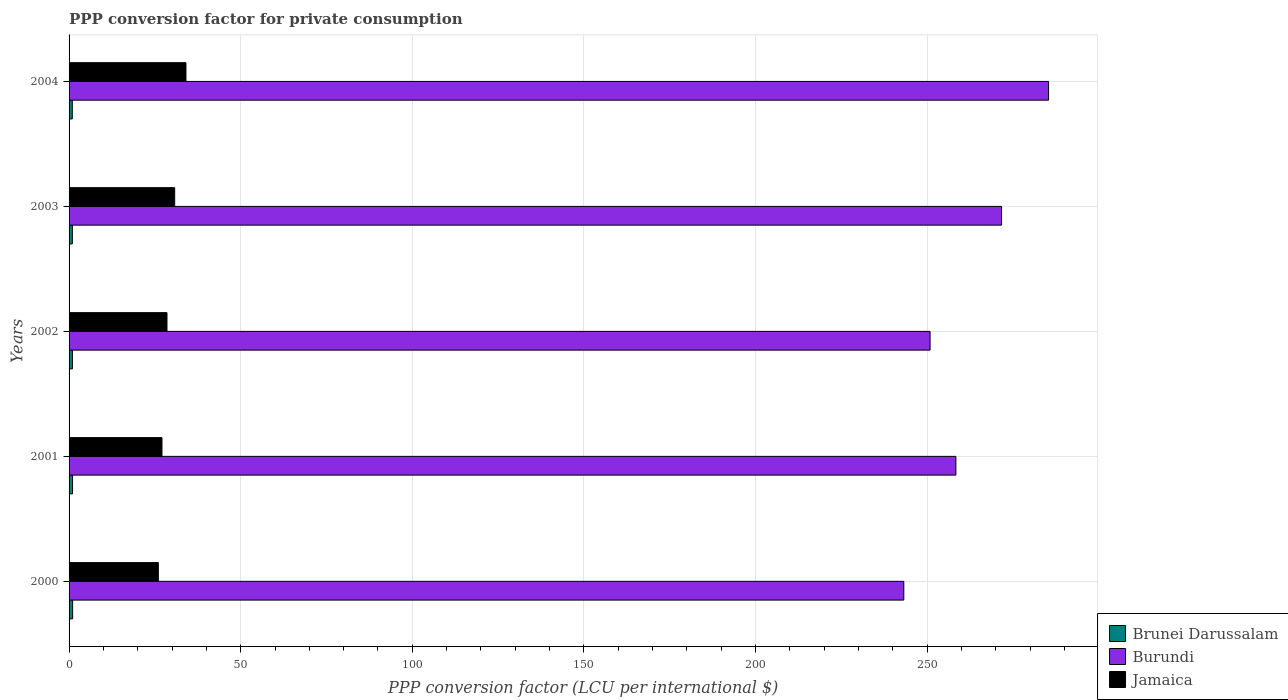How many different coloured bars are there?
Your answer should be compact. 3. How many groups of bars are there?
Provide a succinct answer. 5. Are the number of bars per tick equal to the number of legend labels?
Offer a terse response. Yes. Are the number of bars on each tick of the Y-axis equal?
Make the answer very short. Yes. How many bars are there on the 4th tick from the bottom?
Your response must be concise. 3. What is the label of the 3rd group of bars from the top?
Your answer should be compact. 2002. What is the PPP conversion factor for private consumption in Brunei Darussalam in 2003?
Ensure brevity in your answer.  0.96. Across all years, what is the maximum PPP conversion factor for private consumption in Jamaica?
Your answer should be compact. 34.06. Across all years, what is the minimum PPP conversion factor for private consumption in Brunei Darussalam?
Your answer should be compact. 0.94. In which year was the PPP conversion factor for private consumption in Brunei Darussalam maximum?
Your response must be concise. 2000. What is the total PPP conversion factor for private consumption in Brunei Darussalam in the graph?
Your answer should be compact. 4.92. What is the difference between the PPP conversion factor for private consumption in Jamaica in 2001 and that in 2004?
Make the answer very short. -6.99. What is the difference between the PPP conversion factor for private consumption in Jamaica in 2000 and the PPP conversion factor for private consumption in Brunei Darussalam in 2003?
Give a very brief answer. 25.06. What is the average PPP conversion factor for private consumption in Jamaica per year?
Ensure brevity in your answer.  29.29. In the year 2001, what is the difference between the PPP conversion factor for private consumption in Jamaica and PPP conversion factor for private consumption in Burundi?
Offer a terse response. -231.32. What is the ratio of the PPP conversion factor for private consumption in Burundi in 2000 to that in 2002?
Offer a very short reply. 0.97. Is the PPP conversion factor for private consumption in Brunei Darussalam in 2001 less than that in 2004?
Ensure brevity in your answer.  No. What is the difference between the highest and the second highest PPP conversion factor for private consumption in Brunei Darussalam?
Your response must be concise. 0.02. What is the difference between the highest and the lowest PPP conversion factor for private consumption in Jamaica?
Offer a very short reply. 8.04. In how many years, is the PPP conversion factor for private consumption in Jamaica greater than the average PPP conversion factor for private consumption in Jamaica taken over all years?
Make the answer very short. 2. Is the sum of the PPP conversion factor for private consumption in Brunei Darussalam in 2002 and 2003 greater than the maximum PPP conversion factor for private consumption in Burundi across all years?
Provide a succinct answer. No. What does the 3rd bar from the top in 2003 represents?
Your response must be concise. Brunei Darussalam. What does the 1st bar from the bottom in 2000 represents?
Keep it short and to the point. Brunei Darussalam. How many bars are there?
Provide a succinct answer. 15. Are all the bars in the graph horizontal?
Keep it short and to the point. Yes. How many years are there in the graph?
Keep it short and to the point. 5. Are the values on the major ticks of X-axis written in scientific E-notation?
Offer a terse response. No. Where does the legend appear in the graph?
Give a very brief answer. Bottom right. What is the title of the graph?
Give a very brief answer. PPP conversion factor for private consumption. What is the label or title of the X-axis?
Ensure brevity in your answer.  PPP conversion factor (LCU per international $). What is the PPP conversion factor (LCU per international $) in Brunei Darussalam in 2000?
Make the answer very short. 1.04. What is the PPP conversion factor (LCU per international $) of Burundi in 2000?
Provide a short and direct response. 243.21. What is the PPP conversion factor (LCU per international $) in Jamaica in 2000?
Give a very brief answer. 26.01. What is the PPP conversion factor (LCU per international $) in Brunei Darussalam in 2001?
Make the answer very short. 1.01. What is the PPP conversion factor (LCU per international $) of Burundi in 2001?
Provide a succinct answer. 258.39. What is the PPP conversion factor (LCU per international $) in Jamaica in 2001?
Keep it short and to the point. 27.07. What is the PPP conversion factor (LCU per international $) of Brunei Darussalam in 2002?
Provide a succinct answer. 0.98. What is the PPP conversion factor (LCU per international $) in Burundi in 2002?
Give a very brief answer. 250.87. What is the PPP conversion factor (LCU per international $) in Jamaica in 2002?
Offer a very short reply. 28.53. What is the PPP conversion factor (LCU per international $) of Brunei Darussalam in 2003?
Ensure brevity in your answer.  0.96. What is the PPP conversion factor (LCU per international $) of Burundi in 2003?
Offer a very short reply. 271.7. What is the PPP conversion factor (LCU per international $) in Jamaica in 2003?
Provide a short and direct response. 30.77. What is the PPP conversion factor (LCU per international $) of Brunei Darussalam in 2004?
Make the answer very short. 0.94. What is the PPP conversion factor (LCU per international $) in Burundi in 2004?
Make the answer very short. 285.39. What is the PPP conversion factor (LCU per international $) of Jamaica in 2004?
Offer a very short reply. 34.06. Across all years, what is the maximum PPP conversion factor (LCU per international $) in Brunei Darussalam?
Offer a terse response. 1.04. Across all years, what is the maximum PPP conversion factor (LCU per international $) in Burundi?
Your answer should be very brief. 285.39. Across all years, what is the maximum PPP conversion factor (LCU per international $) of Jamaica?
Your response must be concise. 34.06. Across all years, what is the minimum PPP conversion factor (LCU per international $) in Brunei Darussalam?
Give a very brief answer. 0.94. Across all years, what is the minimum PPP conversion factor (LCU per international $) of Burundi?
Your answer should be very brief. 243.21. Across all years, what is the minimum PPP conversion factor (LCU per international $) in Jamaica?
Keep it short and to the point. 26.01. What is the total PPP conversion factor (LCU per international $) in Brunei Darussalam in the graph?
Offer a terse response. 4.92. What is the total PPP conversion factor (LCU per international $) in Burundi in the graph?
Ensure brevity in your answer.  1309.55. What is the total PPP conversion factor (LCU per international $) in Jamaica in the graph?
Keep it short and to the point. 146.44. What is the difference between the PPP conversion factor (LCU per international $) of Brunei Darussalam in 2000 and that in 2001?
Provide a short and direct response. 0.02. What is the difference between the PPP conversion factor (LCU per international $) in Burundi in 2000 and that in 2001?
Offer a very short reply. -15.18. What is the difference between the PPP conversion factor (LCU per international $) in Jamaica in 2000 and that in 2001?
Give a very brief answer. -1.05. What is the difference between the PPP conversion factor (LCU per international $) of Brunei Darussalam in 2000 and that in 2002?
Make the answer very short. 0.06. What is the difference between the PPP conversion factor (LCU per international $) of Burundi in 2000 and that in 2002?
Ensure brevity in your answer.  -7.66. What is the difference between the PPP conversion factor (LCU per international $) of Jamaica in 2000 and that in 2002?
Offer a terse response. -2.52. What is the difference between the PPP conversion factor (LCU per international $) of Brunei Darussalam in 2000 and that in 2003?
Provide a short and direct response. 0.08. What is the difference between the PPP conversion factor (LCU per international $) of Burundi in 2000 and that in 2003?
Ensure brevity in your answer.  -28.49. What is the difference between the PPP conversion factor (LCU per international $) of Jamaica in 2000 and that in 2003?
Make the answer very short. -4.76. What is the difference between the PPP conversion factor (LCU per international $) of Brunei Darussalam in 2000 and that in 2004?
Offer a very short reply. 0.1. What is the difference between the PPP conversion factor (LCU per international $) in Burundi in 2000 and that in 2004?
Your answer should be very brief. -42.18. What is the difference between the PPP conversion factor (LCU per international $) in Jamaica in 2000 and that in 2004?
Offer a terse response. -8.04. What is the difference between the PPP conversion factor (LCU per international $) in Brunei Darussalam in 2001 and that in 2002?
Offer a terse response. 0.04. What is the difference between the PPP conversion factor (LCU per international $) of Burundi in 2001 and that in 2002?
Ensure brevity in your answer.  7.52. What is the difference between the PPP conversion factor (LCU per international $) in Jamaica in 2001 and that in 2002?
Ensure brevity in your answer.  -1.46. What is the difference between the PPP conversion factor (LCU per international $) of Brunei Darussalam in 2001 and that in 2003?
Give a very brief answer. 0.06. What is the difference between the PPP conversion factor (LCU per international $) of Burundi in 2001 and that in 2003?
Ensure brevity in your answer.  -13.31. What is the difference between the PPP conversion factor (LCU per international $) of Jamaica in 2001 and that in 2003?
Your answer should be compact. -3.71. What is the difference between the PPP conversion factor (LCU per international $) of Brunei Darussalam in 2001 and that in 2004?
Keep it short and to the point. 0.08. What is the difference between the PPP conversion factor (LCU per international $) of Burundi in 2001 and that in 2004?
Keep it short and to the point. -27. What is the difference between the PPP conversion factor (LCU per international $) of Jamaica in 2001 and that in 2004?
Provide a succinct answer. -6.99. What is the difference between the PPP conversion factor (LCU per international $) in Brunei Darussalam in 2002 and that in 2003?
Provide a short and direct response. 0.02. What is the difference between the PPP conversion factor (LCU per international $) in Burundi in 2002 and that in 2003?
Make the answer very short. -20.83. What is the difference between the PPP conversion factor (LCU per international $) of Jamaica in 2002 and that in 2003?
Offer a terse response. -2.25. What is the difference between the PPP conversion factor (LCU per international $) in Brunei Darussalam in 2002 and that in 2004?
Provide a short and direct response. 0.04. What is the difference between the PPP conversion factor (LCU per international $) of Burundi in 2002 and that in 2004?
Offer a very short reply. -34.52. What is the difference between the PPP conversion factor (LCU per international $) in Jamaica in 2002 and that in 2004?
Provide a short and direct response. -5.53. What is the difference between the PPP conversion factor (LCU per international $) of Brunei Darussalam in 2003 and that in 2004?
Provide a short and direct response. 0.02. What is the difference between the PPP conversion factor (LCU per international $) in Burundi in 2003 and that in 2004?
Your answer should be very brief. -13.69. What is the difference between the PPP conversion factor (LCU per international $) in Jamaica in 2003 and that in 2004?
Ensure brevity in your answer.  -3.28. What is the difference between the PPP conversion factor (LCU per international $) in Brunei Darussalam in 2000 and the PPP conversion factor (LCU per international $) in Burundi in 2001?
Provide a succinct answer. -257.35. What is the difference between the PPP conversion factor (LCU per international $) of Brunei Darussalam in 2000 and the PPP conversion factor (LCU per international $) of Jamaica in 2001?
Your answer should be very brief. -26.03. What is the difference between the PPP conversion factor (LCU per international $) in Burundi in 2000 and the PPP conversion factor (LCU per international $) in Jamaica in 2001?
Give a very brief answer. 216.15. What is the difference between the PPP conversion factor (LCU per international $) in Brunei Darussalam in 2000 and the PPP conversion factor (LCU per international $) in Burundi in 2002?
Provide a succinct answer. -249.83. What is the difference between the PPP conversion factor (LCU per international $) of Brunei Darussalam in 2000 and the PPP conversion factor (LCU per international $) of Jamaica in 2002?
Your response must be concise. -27.49. What is the difference between the PPP conversion factor (LCU per international $) in Burundi in 2000 and the PPP conversion factor (LCU per international $) in Jamaica in 2002?
Provide a succinct answer. 214.68. What is the difference between the PPP conversion factor (LCU per international $) in Brunei Darussalam in 2000 and the PPP conversion factor (LCU per international $) in Burundi in 2003?
Provide a succinct answer. -270.66. What is the difference between the PPP conversion factor (LCU per international $) in Brunei Darussalam in 2000 and the PPP conversion factor (LCU per international $) in Jamaica in 2003?
Make the answer very short. -29.74. What is the difference between the PPP conversion factor (LCU per international $) of Burundi in 2000 and the PPP conversion factor (LCU per international $) of Jamaica in 2003?
Offer a very short reply. 212.44. What is the difference between the PPP conversion factor (LCU per international $) in Brunei Darussalam in 2000 and the PPP conversion factor (LCU per international $) in Burundi in 2004?
Provide a short and direct response. -284.35. What is the difference between the PPP conversion factor (LCU per international $) of Brunei Darussalam in 2000 and the PPP conversion factor (LCU per international $) of Jamaica in 2004?
Provide a short and direct response. -33.02. What is the difference between the PPP conversion factor (LCU per international $) in Burundi in 2000 and the PPP conversion factor (LCU per international $) in Jamaica in 2004?
Provide a short and direct response. 209.15. What is the difference between the PPP conversion factor (LCU per international $) in Brunei Darussalam in 2001 and the PPP conversion factor (LCU per international $) in Burundi in 2002?
Give a very brief answer. -249.85. What is the difference between the PPP conversion factor (LCU per international $) of Brunei Darussalam in 2001 and the PPP conversion factor (LCU per international $) of Jamaica in 2002?
Provide a short and direct response. -27.51. What is the difference between the PPP conversion factor (LCU per international $) of Burundi in 2001 and the PPP conversion factor (LCU per international $) of Jamaica in 2002?
Your answer should be compact. 229.86. What is the difference between the PPP conversion factor (LCU per international $) of Brunei Darussalam in 2001 and the PPP conversion factor (LCU per international $) of Burundi in 2003?
Offer a very short reply. -270.68. What is the difference between the PPP conversion factor (LCU per international $) of Brunei Darussalam in 2001 and the PPP conversion factor (LCU per international $) of Jamaica in 2003?
Offer a terse response. -29.76. What is the difference between the PPP conversion factor (LCU per international $) of Burundi in 2001 and the PPP conversion factor (LCU per international $) of Jamaica in 2003?
Provide a short and direct response. 227.61. What is the difference between the PPP conversion factor (LCU per international $) of Brunei Darussalam in 2001 and the PPP conversion factor (LCU per international $) of Burundi in 2004?
Keep it short and to the point. -284.37. What is the difference between the PPP conversion factor (LCU per international $) of Brunei Darussalam in 2001 and the PPP conversion factor (LCU per international $) of Jamaica in 2004?
Keep it short and to the point. -33.04. What is the difference between the PPP conversion factor (LCU per international $) of Burundi in 2001 and the PPP conversion factor (LCU per international $) of Jamaica in 2004?
Provide a short and direct response. 224.33. What is the difference between the PPP conversion factor (LCU per international $) in Brunei Darussalam in 2002 and the PPP conversion factor (LCU per international $) in Burundi in 2003?
Your answer should be very brief. -270.72. What is the difference between the PPP conversion factor (LCU per international $) of Brunei Darussalam in 2002 and the PPP conversion factor (LCU per international $) of Jamaica in 2003?
Your answer should be very brief. -29.8. What is the difference between the PPP conversion factor (LCU per international $) of Burundi in 2002 and the PPP conversion factor (LCU per international $) of Jamaica in 2003?
Ensure brevity in your answer.  220.09. What is the difference between the PPP conversion factor (LCU per international $) in Brunei Darussalam in 2002 and the PPP conversion factor (LCU per international $) in Burundi in 2004?
Your response must be concise. -284.41. What is the difference between the PPP conversion factor (LCU per international $) of Brunei Darussalam in 2002 and the PPP conversion factor (LCU per international $) of Jamaica in 2004?
Ensure brevity in your answer.  -33.08. What is the difference between the PPP conversion factor (LCU per international $) of Burundi in 2002 and the PPP conversion factor (LCU per international $) of Jamaica in 2004?
Your response must be concise. 216.81. What is the difference between the PPP conversion factor (LCU per international $) of Brunei Darussalam in 2003 and the PPP conversion factor (LCU per international $) of Burundi in 2004?
Make the answer very short. -284.43. What is the difference between the PPP conversion factor (LCU per international $) of Brunei Darussalam in 2003 and the PPP conversion factor (LCU per international $) of Jamaica in 2004?
Your answer should be very brief. -33.1. What is the difference between the PPP conversion factor (LCU per international $) in Burundi in 2003 and the PPP conversion factor (LCU per international $) in Jamaica in 2004?
Give a very brief answer. 237.64. What is the average PPP conversion factor (LCU per international $) in Brunei Darussalam per year?
Offer a very short reply. 0.98. What is the average PPP conversion factor (LCU per international $) in Burundi per year?
Your response must be concise. 261.91. What is the average PPP conversion factor (LCU per international $) in Jamaica per year?
Ensure brevity in your answer.  29.29. In the year 2000, what is the difference between the PPP conversion factor (LCU per international $) in Brunei Darussalam and PPP conversion factor (LCU per international $) in Burundi?
Your response must be concise. -242.17. In the year 2000, what is the difference between the PPP conversion factor (LCU per international $) of Brunei Darussalam and PPP conversion factor (LCU per international $) of Jamaica?
Provide a succinct answer. -24.98. In the year 2000, what is the difference between the PPP conversion factor (LCU per international $) in Burundi and PPP conversion factor (LCU per international $) in Jamaica?
Your answer should be compact. 217.2. In the year 2001, what is the difference between the PPP conversion factor (LCU per international $) in Brunei Darussalam and PPP conversion factor (LCU per international $) in Burundi?
Ensure brevity in your answer.  -257.37. In the year 2001, what is the difference between the PPP conversion factor (LCU per international $) in Brunei Darussalam and PPP conversion factor (LCU per international $) in Jamaica?
Make the answer very short. -26.05. In the year 2001, what is the difference between the PPP conversion factor (LCU per international $) of Burundi and PPP conversion factor (LCU per international $) of Jamaica?
Keep it short and to the point. 231.32. In the year 2002, what is the difference between the PPP conversion factor (LCU per international $) of Brunei Darussalam and PPP conversion factor (LCU per international $) of Burundi?
Keep it short and to the point. -249.89. In the year 2002, what is the difference between the PPP conversion factor (LCU per international $) of Brunei Darussalam and PPP conversion factor (LCU per international $) of Jamaica?
Give a very brief answer. -27.55. In the year 2002, what is the difference between the PPP conversion factor (LCU per international $) of Burundi and PPP conversion factor (LCU per international $) of Jamaica?
Your response must be concise. 222.34. In the year 2003, what is the difference between the PPP conversion factor (LCU per international $) of Brunei Darussalam and PPP conversion factor (LCU per international $) of Burundi?
Your response must be concise. -270.74. In the year 2003, what is the difference between the PPP conversion factor (LCU per international $) in Brunei Darussalam and PPP conversion factor (LCU per international $) in Jamaica?
Your answer should be very brief. -29.82. In the year 2003, what is the difference between the PPP conversion factor (LCU per international $) of Burundi and PPP conversion factor (LCU per international $) of Jamaica?
Your answer should be compact. 240.92. In the year 2004, what is the difference between the PPP conversion factor (LCU per international $) of Brunei Darussalam and PPP conversion factor (LCU per international $) of Burundi?
Give a very brief answer. -284.45. In the year 2004, what is the difference between the PPP conversion factor (LCU per international $) of Brunei Darussalam and PPP conversion factor (LCU per international $) of Jamaica?
Offer a terse response. -33.12. In the year 2004, what is the difference between the PPP conversion factor (LCU per international $) of Burundi and PPP conversion factor (LCU per international $) of Jamaica?
Ensure brevity in your answer.  251.33. What is the ratio of the PPP conversion factor (LCU per international $) in Brunei Darussalam in 2000 to that in 2001?
Your answer should be very brief. 1.02. What is the ratio of the PPP conversion factor (LCU per international $) of Burundi in 2000 to that in 2001?
Ensure brevity in your answer.  0.94. What is the ratio of the PPP conversion factor (LCU per international $) of Jamaica in 2000 to that in 2001?
Your answer should be very brief. 0.96. What is the ratio of the PPP conversion factor (LCU per international $) in Brunei Darussalam in 2000 to that in 2002?
Keep it short and to the point. 1.06. What is the ratio of the PPP conversion factor (LCU per international $) in Burundi in 2000 to that in 2002?
Offer a terse response. 0.97. What is the ratio of the PPP conversion factor (LCU per international $) in Jamaica in 2000 to that in 2002?
Offer a terse response. 0.91. What is the ratio of the PPP conversion factor (LCU per international $) in Brunei Darussalam in 2000 to that in 2003?
Your answer should be compact. 1.08. What is the ratio of the PPP conversion factor (LCU per international $) in Burundi in 2000 to that in 2003?
Give a very brief answer. 0.9. What is the ratio of the PPP conversion factor (LCU per international $) in Jamaica in 2000 to that in 2003?
Offer a very short reply. 0.85. What is the ratio of the PPP conversion factor (LCU per international $) of Brunei Darussalam in 2000 to that in 2004?
Give a very brief answer. 1.1. What is the ratio of the PPP conversion factor (LCU per international $) of Burundi in 2000 to that in 2004?
Keep it short and to the point. 0.85. What is the ratio of the PPP conversion factor (LCU per international $) in Jamaica in 2000 to that in 2004?
Your answer should be very brief. 0.76. What is the ratio of the PPP conversion factor (LCU per international $) of Brunei Darussalam in 2001 to that in 2002?
Give a very brief answer. 1.04. What is the ratio of the PPP conversion factor (LCU per international $) of Jamaica in 2001 to that in 2002?
Offer a terse response. 0.95. What is the ratio of the PPP conversion factor (LCU per international $) in Brunei Darussalam in 2001 to that in 2003?
Keep it short and to the point. 1.06. What is the ratio of the PPP conversion factor (LCU per international $) in Burundi in 2001 to that in 2003?
Offer a terse response. 0.95. What is the ratio of the PPP conversion factor (LCU per international $) in Jamaica in 2001 to that in 2003?
Provide a succinct answer. 0.88. What is the ratio of the PPP conversion factor (LCU per international $) in Burundi in 2001 to that in 2004?
Offer a very short reply. 0.91. What is the ratio of the PPP conversion factor (LCU per international $) of Jamaica in 2001 to that in 2004?
Keep it short and to the point. 0.79. What is the ratio of the PPP conversion factor (LCU per international $) of Brunei Darussalam in 2002 to that in 2003?
Your answer should be very brief. 1.02. What is the ratio of the PPP conversion factor (LCU per international $) in Burundi in 2002 to that in 2003?
Give a very brief answer. 0.92. What is the ratio of the PPP conversion factor (LCU per international $) in Jamaica in 2002 to that in 2003?
Offer a very short reply. 0.93. What is the ratio of the PPP conversion factor (LCU per international $) of Brunei Darussalam in 2002 to that in 2004?
Keep it short and to the point. 1.04. What is the ratio of the PPP conversion factor (LCU per international $) in Burundi in 2002 to that in 2004?
Your answer should be very brief. 0.88. What is the ratio of the PPP conversion factor (LCU per international $) of Jamaica in 2002 to that in 2004?
Provide a succinct answer. 0.84. What is the ratio of the PPP conversion factor (LCU per international $) in Brunei Darussalam in 2003 to that in 2004?
Offer a terse response. 1.02. What is the ratio of the PPP conversion factor (LCU per international $) in Burundi in 2003 to that in 2004?
Your response must be concise. 0.95. What is the ratio of the PPP conversion factor (LCU per international $) in Jamaica in 2003 to that in 2004?
Keep it short and to the point. 0.9. What is the difference between the highest and the second highest PPP conversion factor (LCU per international $) in Brunei Darussalam?
Your answer should be compact. 0.02. What is the difference between the highest and the second highest PPP conversion factor (LCU per international $) of Burundi?
Offer a terse response. 13.69. What is the difference between the highest and the second highest PPP conversion factor (LCU per international $) in Jamaica?
Ensure brevity in your answer.  3.28. What is the difference between the highest and the lowest PPP conversion factor (LCU per international $) of Brunei Darussalam?
Keep it short and to the point. 0.1. What is the difference between the highest and the lowest PPP conversion factor (LCU per international $) of Burundi?
Offer a very short reply. 42.18. What is the difference between the highest and the lowest PPP conversion factor (LCU per international $) in Jamaica?
Your answer should be compact. 8.04. 